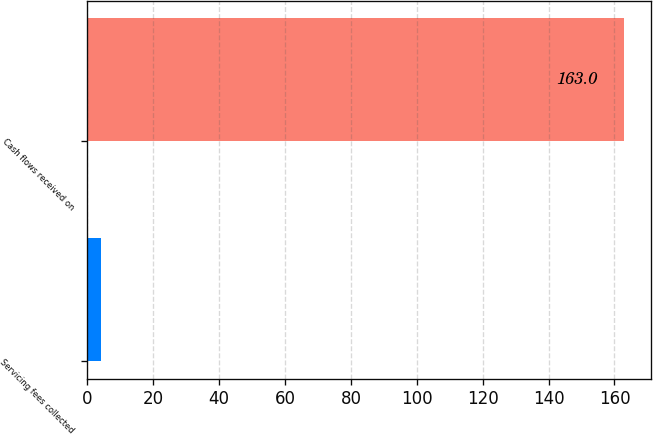<chart> <loc_0><loc_0><loc_500><loc_500><bar_chart><fcel>Servicing fees collected<fcel>Cash flows received on<nl><fcel>4<fcel>163<nl></chart> 